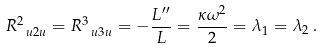<formula> <loc_0><loc_0><loc_500><loc_500>R ^ { 2 } _ { \ u 2 u } = R ^ { 3 } _ { \ u 3 u } = - \frac { L ^ { \prime \prime } } { L } = \frac { \kappa \omega ^ { 2 } } { 2 } = \lambda _ { 1 } = \lambda _ { 2 } \, .</formula> 